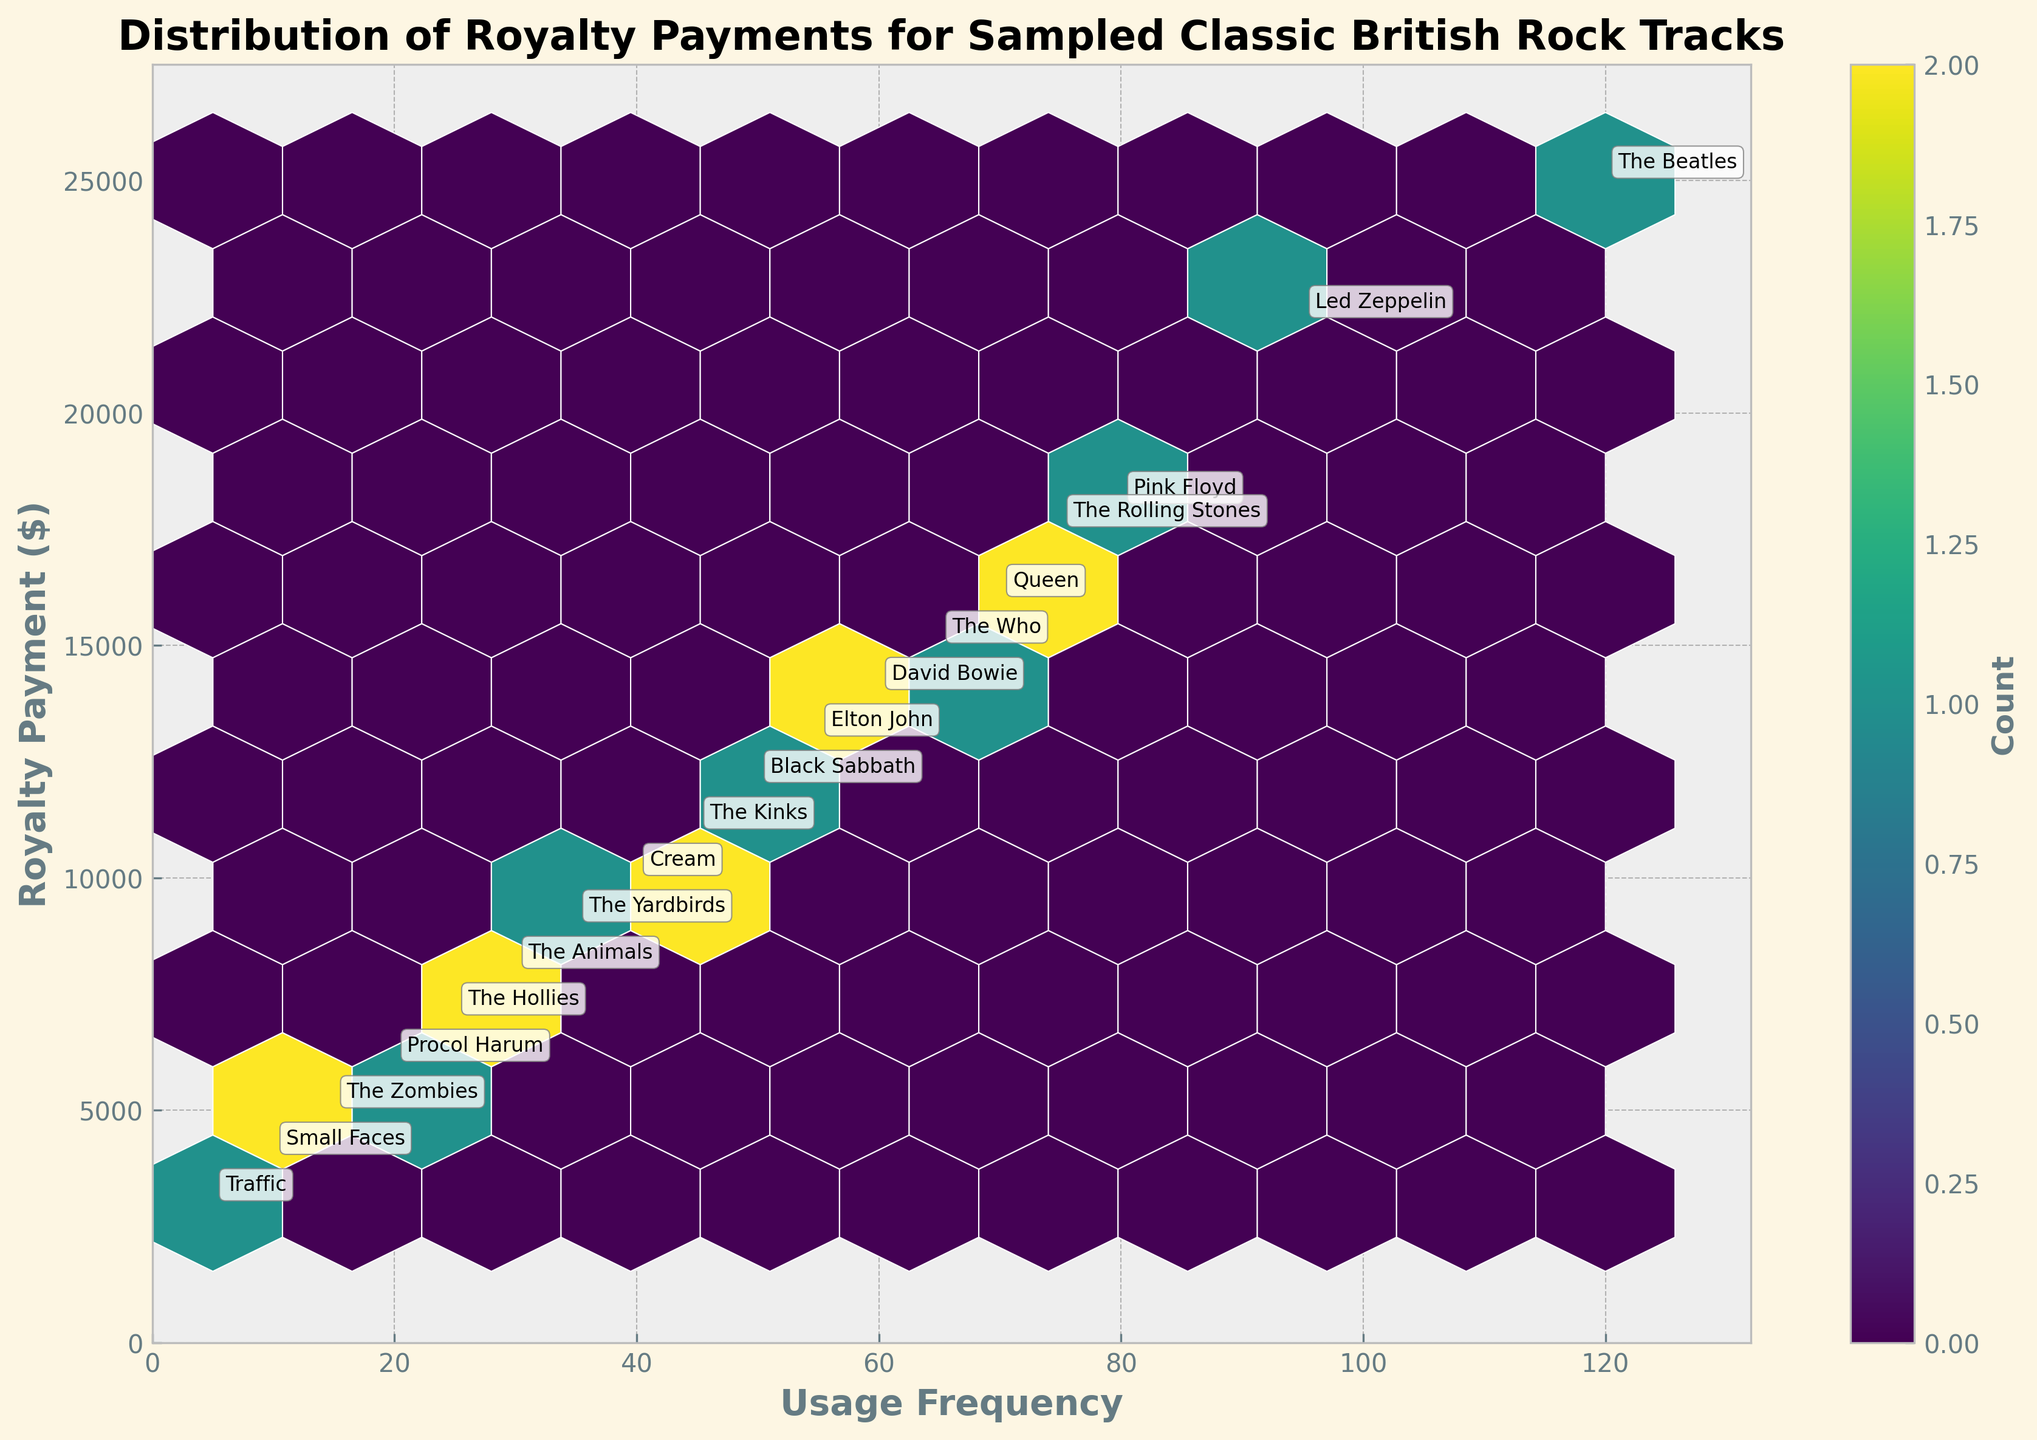What is the highest royalty payment shown on the plot? The highest royalty payment can be seen by identifying the topmost data point on the vertical axis which is labeled "Royalty Payment ($)". The topmost payment is $25,000.
Answer: $25,000 Which original artist has the highest usage frequency? To find the artist with the highest usage frequency, locate the point furthest to the right on the horizontal axis labeled "Usage Frequency". This point is annotated with "The Beatles".
Answer: The Beatles What is the general relationship between usage frequency and royalty payment? Examine the trend of the data points in the hexbin plot. As the usage frequency increases along the horizontal axis, the royalty payments generally increase along the vertical axis, suggesting a positive correlation.
Answer: Positive correlation How many original artists have a usage frequency above 50? Identify the data points where the horizontal axis "Usage Frequency" is greater than 50, and count the number of these points. These artists are "The Beatles", "Led Zeppelin", "Pink Floyd", "The Rolling Stones", "Queen", "The Who", "David Bowie", and "Elton John" — totaling 8 artists.
Answer: 8 Which artist has the lowest royalty payment, and what is the amount? Locate the bottommost point on the vertical axis labeled "Royalty Payment ($)". This point is annotated with "Traffic".
Answer: Traffic, $3,000 In which grid size does the highest count of data points fall? Identify the densest (most color-intense) hexagonal bin on the plot. The colorbar indicates the count of data points in each bin. The exact count can vary depending on grid size, but generally, this can be observed as the most vibrant hue on the plot.
Answer: The densest hexagonal bin (specific count depends on the color intensity) What is the average royalty payment for artists with usage frequencies above 80? Identify the data points where the "Usage Frequency" is greater than 80, and calculate the average of their royalty payments. These include "The Beatles" ($25,000), "Led Zeppelin" ($22,000), and "Pink Floyd" ($18,000). The average is calculated as (25,000 + 22,000 + 18,000) / 3 = $21,666.67.
Answer: $21,666.67 Rank the top three artists by royalty payment from highest to lowest. Arrange the artists by their royalty payments, the top three are "The Beatles" ($25,000), "Led Zeppelin" ($22,000), and "Pink Floyd" ($18,000).
Answer: The Beatles, Led Zeppelin, Pink Floyd How does the royalty payment of "The Rolling Stones" compare to "Queen"? Check the vertical positions of the annotated points for "The Rolling Stones" and "Queen". "The Rolling Stones" has a royalty payment of $17,500, and "Queen" has $16,000. Thus, "The Rolling Stones" have a higher payment.
Answer: The Rolling Stones' royalty payment is higher What is the median usage frequency across all artists? To find the median usage frequency, list all frequencies: [120, 95, 80, 75, 70, 65, 60, 55, 50, 45, 40, 35, 30, 25, 20, 15, 10, 5]. The middle value (median) in this sorted list (18 values) is the average of the 9th and 10th values, which are 50 and 55. The median is (50 + 55) / 2 = 52.5.
Answer: 52.5 